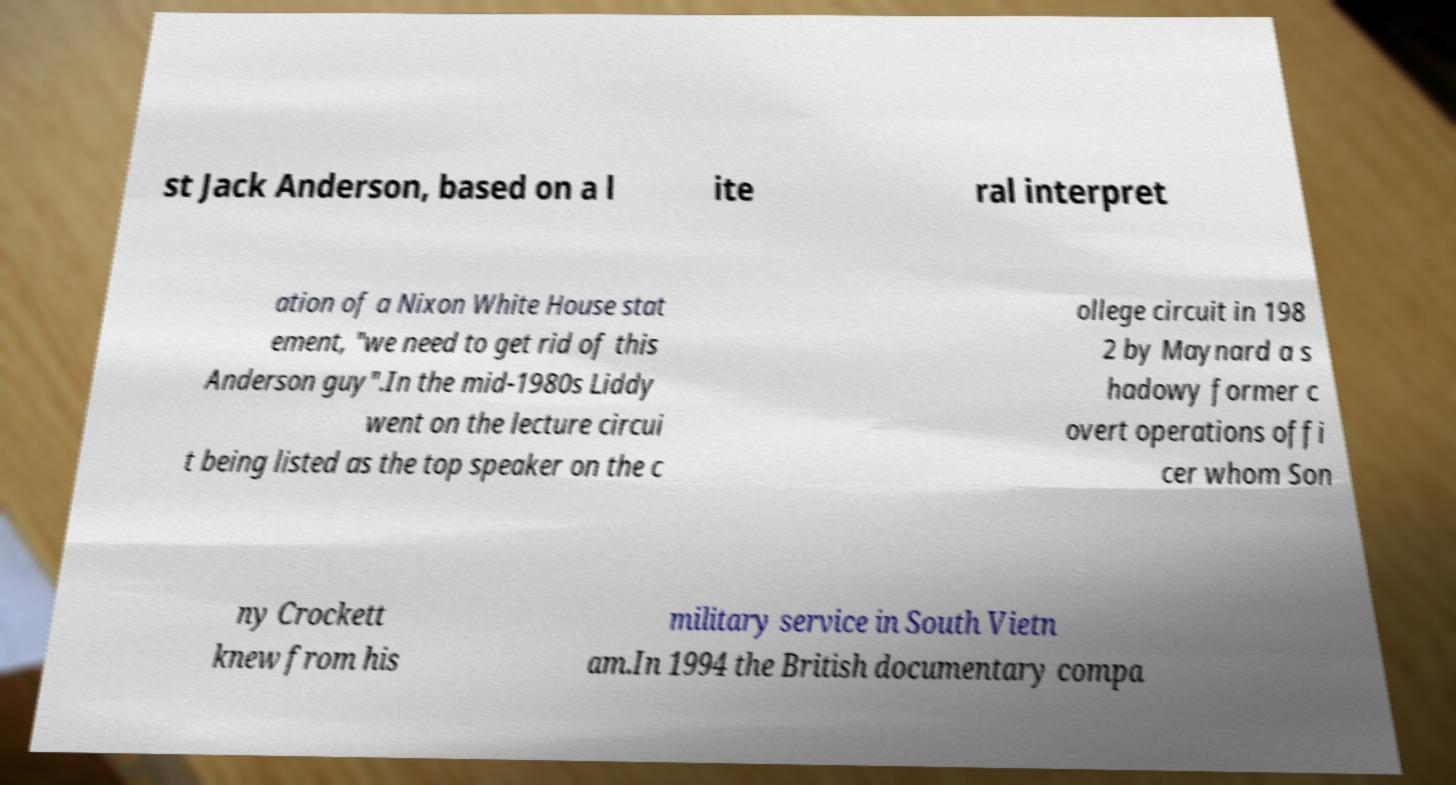For documentation purposes, I need the text within this image transcribed. Could you provide that? st Jack Anderson, based on a l ite ral interpret ation of a Nixon White House stat ement, "we need to get rid of this Anderson guy".In the mid-1980s Liddy went on the lecture circui t being listed as the top speaker on the c ollege circuit in 198 2 by Maynard a s hadowy former c overt operations offi cer whom Son ny Crockett knew from his military service in South Vietn am.In 1994 the British documentary compa 